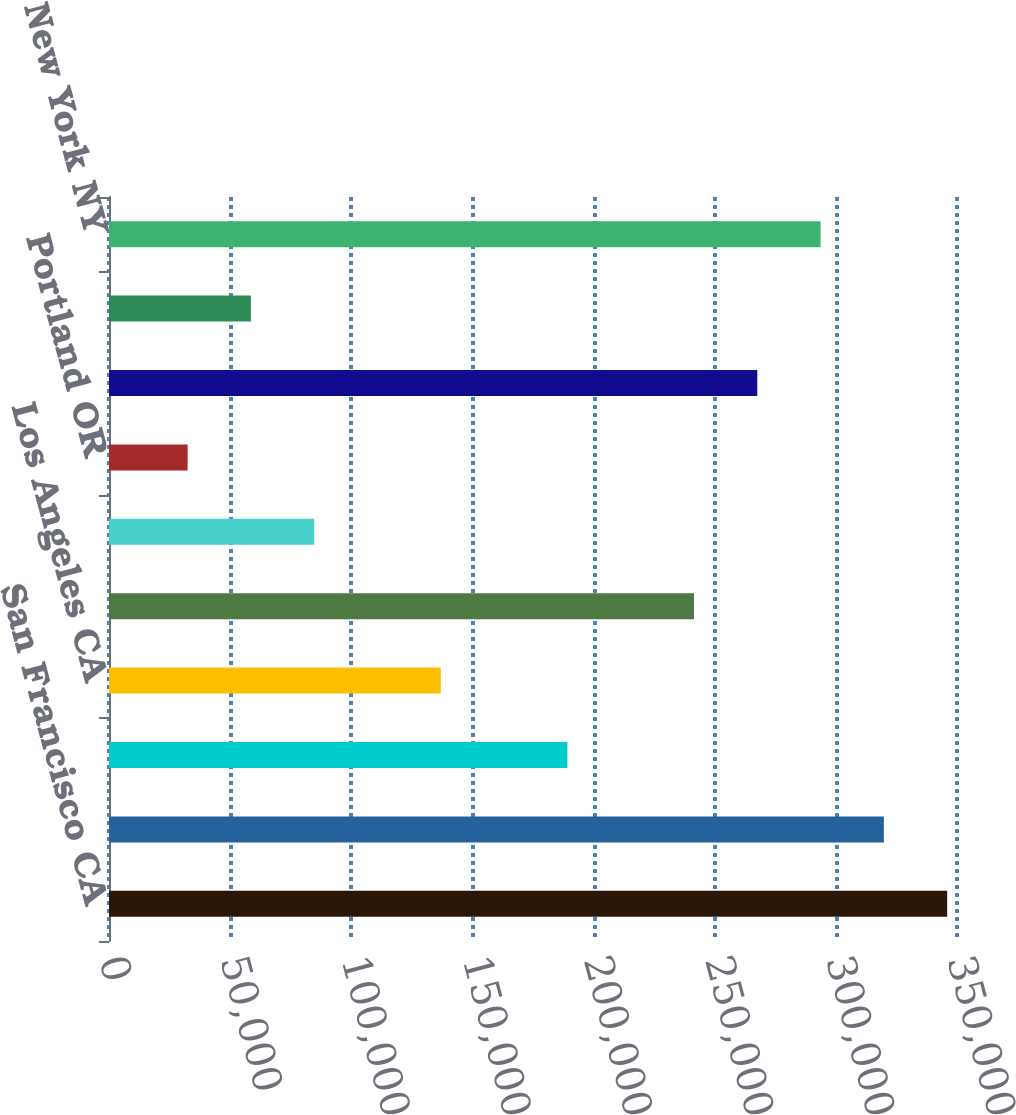<chart> <loc_0><loc_0><loc_500><loc_500><bar_chart><fcel>San Francisco CA<fcel>Orange County CA<fcel>Seattle WA<fcel>Los Angeles CA<fcel>Monterey Peninsula CA<fcel>Other Southern California<fcel>Portland OR<fcel>Metropolitan DC<fcel>Baltimore MD<fcel>New York NY<nl><fcel>345943<fcel>319818<fcel>189195<fcel>136946<fcel>241444<fcel>84696.1<fcel>32446.7<fcel>267569<fcel>58571.4<fcel>293694<nl></chart> 